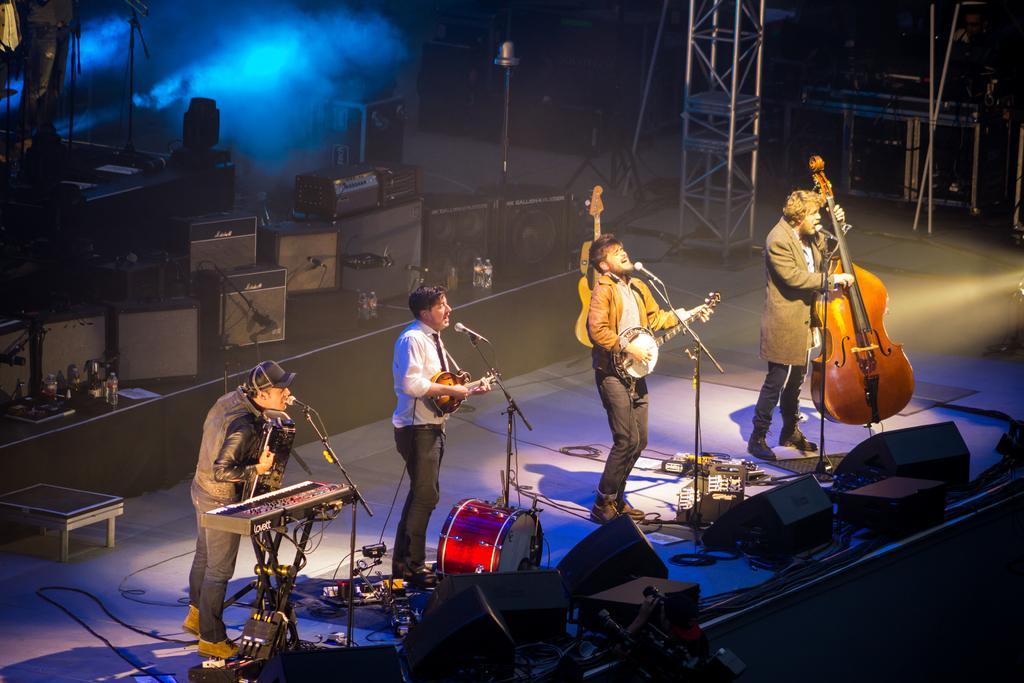Please provide a concise description of this image. This is a picture of a live concert. In the picture there is a stage. On the left there is a person standing playing keyboard and other musical instrument and singing into microphone. In the center a person is standing and playing a musical instrument and singing. In the center there is another person standing and playing a musical instrument and singing into microphone. On the right there is a person standing and playing a musical instrument and singing. On the background there are many boxes. In the background there is smoke and light. In the foreground of the image there are lights and speakers. On the top right there is a table and some instruments.. 